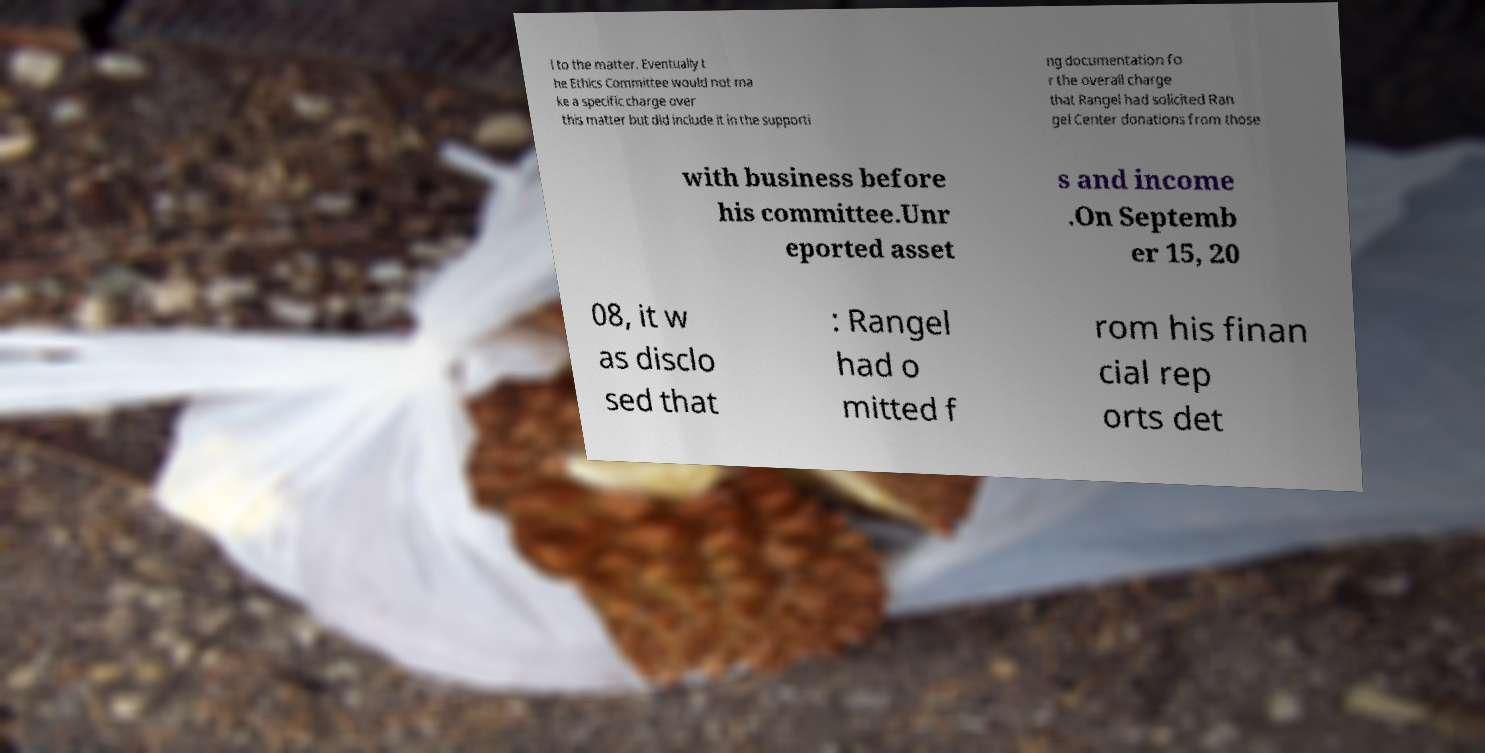Could you assist in decoding the text presented in this image and type it out clearly? l to the matter. Eventually t he Ethics Committee would not ma ke a specific charge over this matter but did include it in the supporti ng documentation fo r the overall charge that Rangel had solicited Ran gel Center donations from those with business before his committee.Unr eported asset s and income .On Septemb er 15, 20 08, it w as disclo sed that : Rangel had o mitted f rom his finan cial rep orts det 